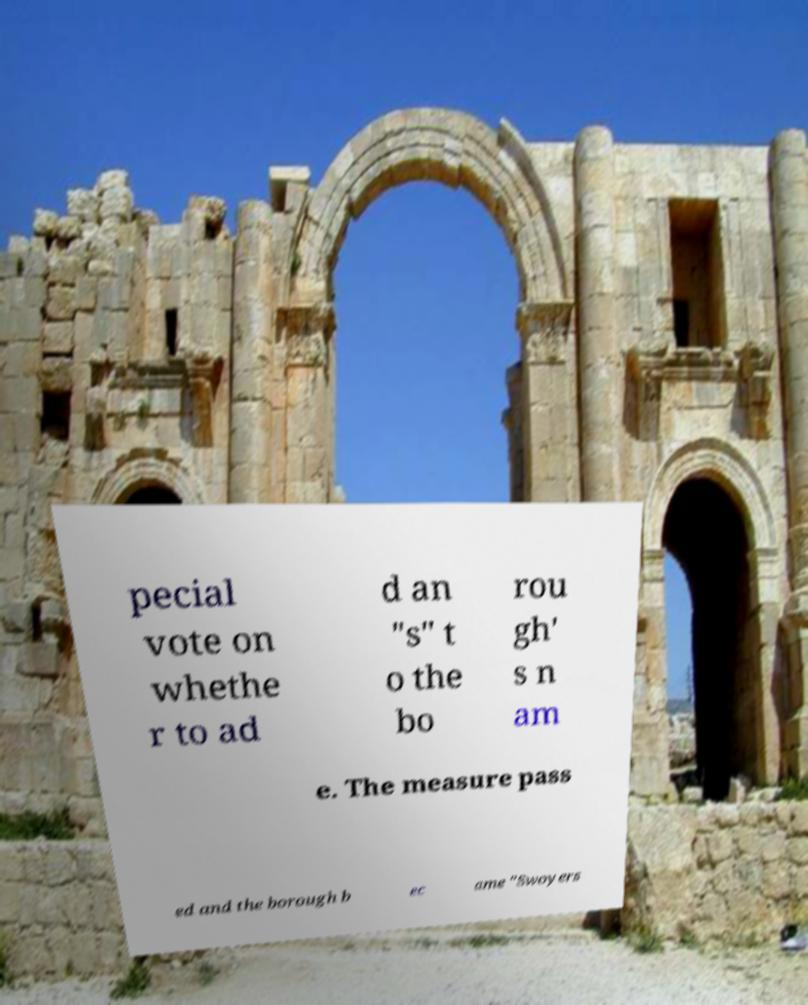Can you read and provide the text displayed in the image?This photo seems to have some interesting text. Can you extract and type it out for me? pecial vote on whethe r to ad d an "s" t o the bo rou gh' s n am e. The measure pass ed and the borough b ec ame "Swoyers 